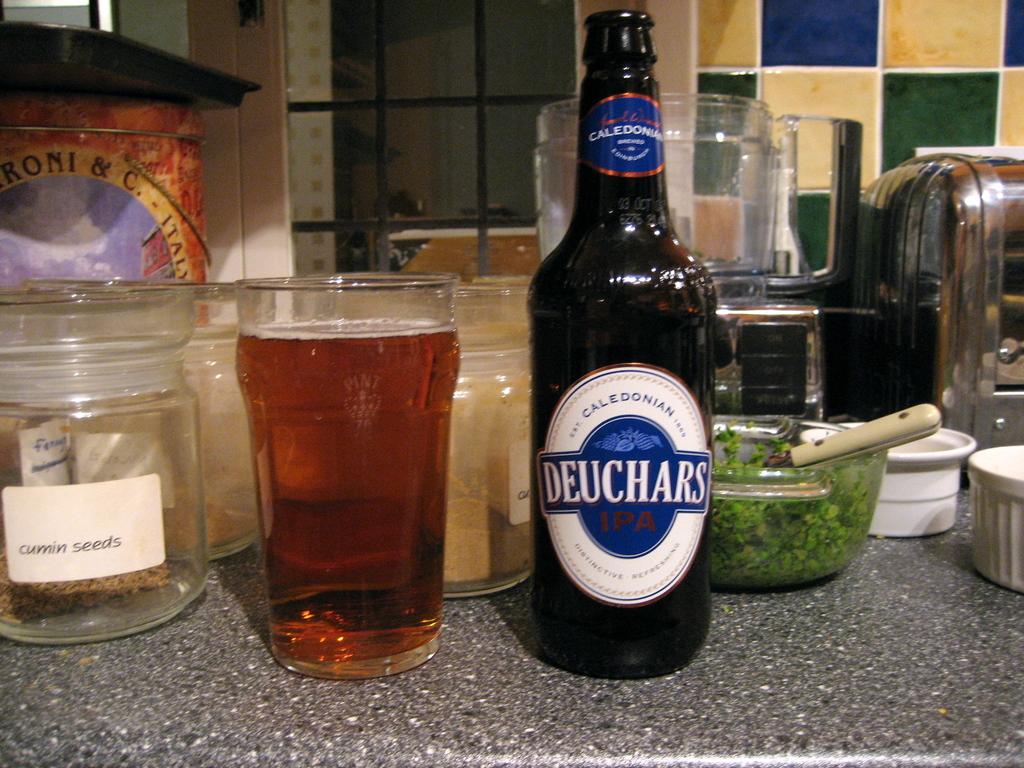What's the brand of this beer?
Your answer should be very brief. Deuchars. 